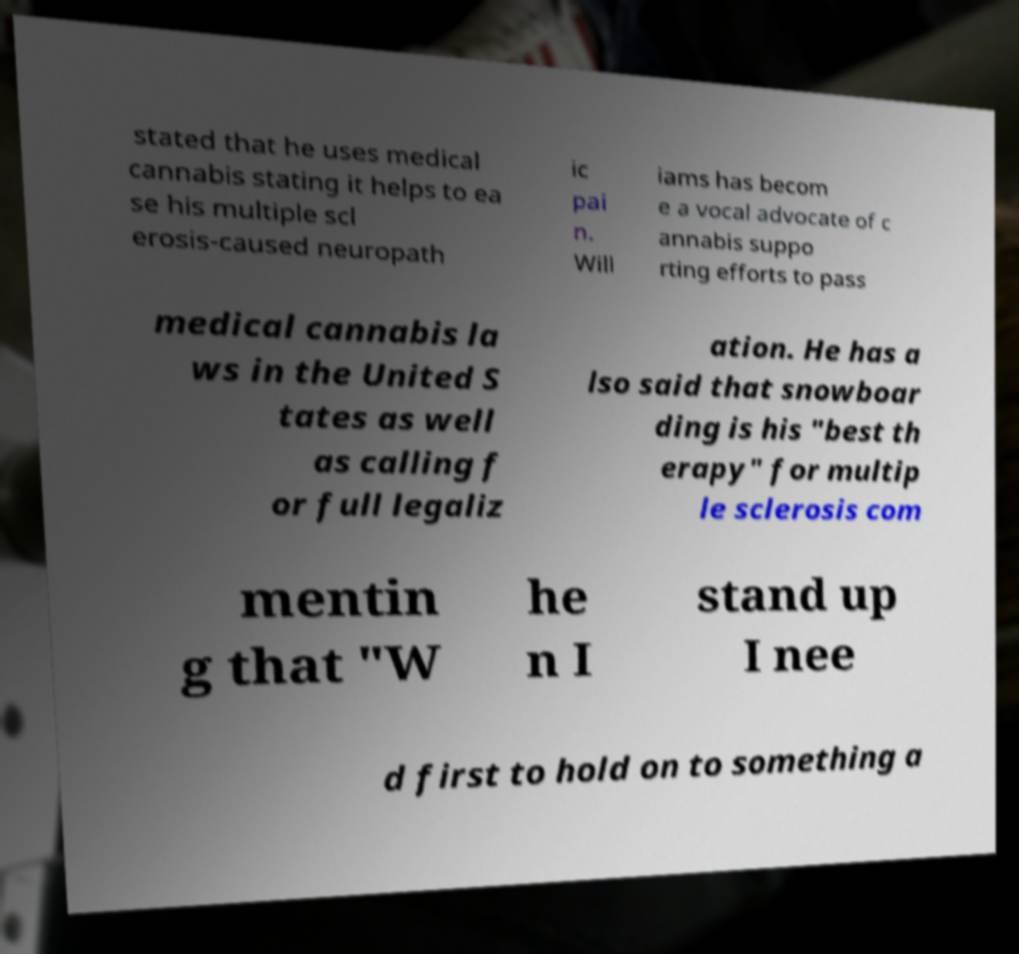Please identify and transcribe the text found in this image. stated that he uses medical cannabis stating it helps to ea se his multiple scl erosis-caused neuropath ic pai n. Will iams has becom e a vocal advocate of c annabis suppo rting efforts to pass medical cannabis la ws in the United S tates as well as calling f or full legaliz ation. He has a lso said that snowboar ding is his "best th erapy" for multip le sclerosis com mentin g that "W he n I stand up I nee d first to hold on to something a 